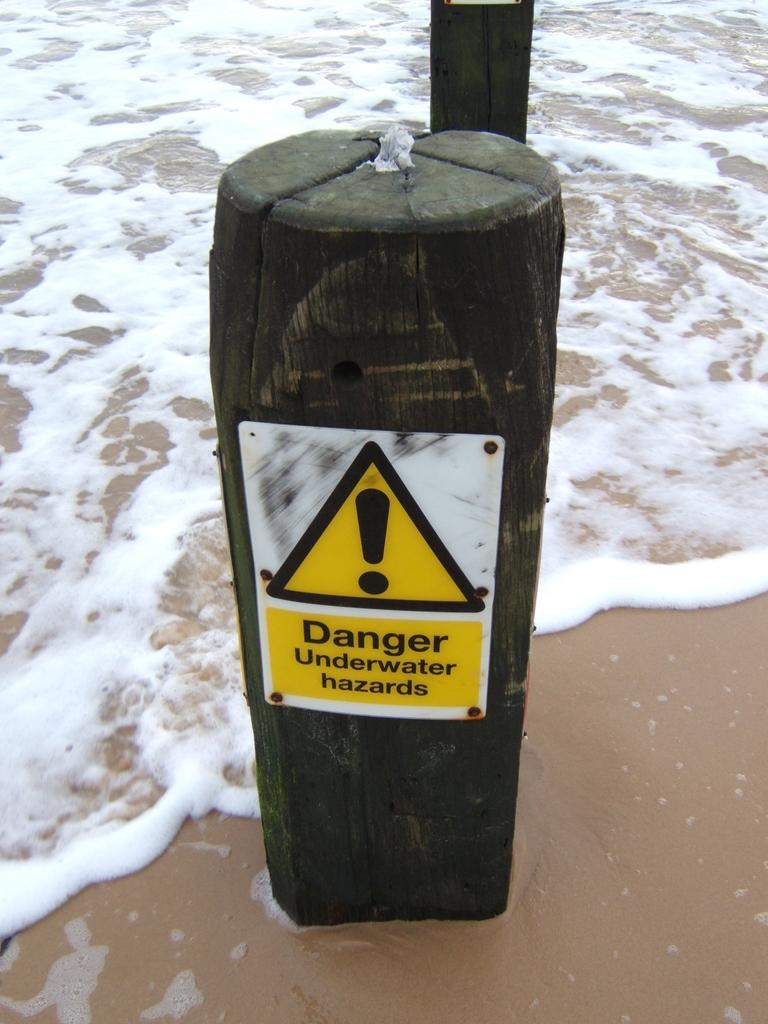<image>
Provide a brief description of the given image. A large log on the beach, where the tide is rolling in, has a danger sign on it, warning people of underwater hazards. 